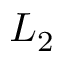<formula> <loc_0><loc_0><loc_500><loc_500>L _ { 2 }</formula> 